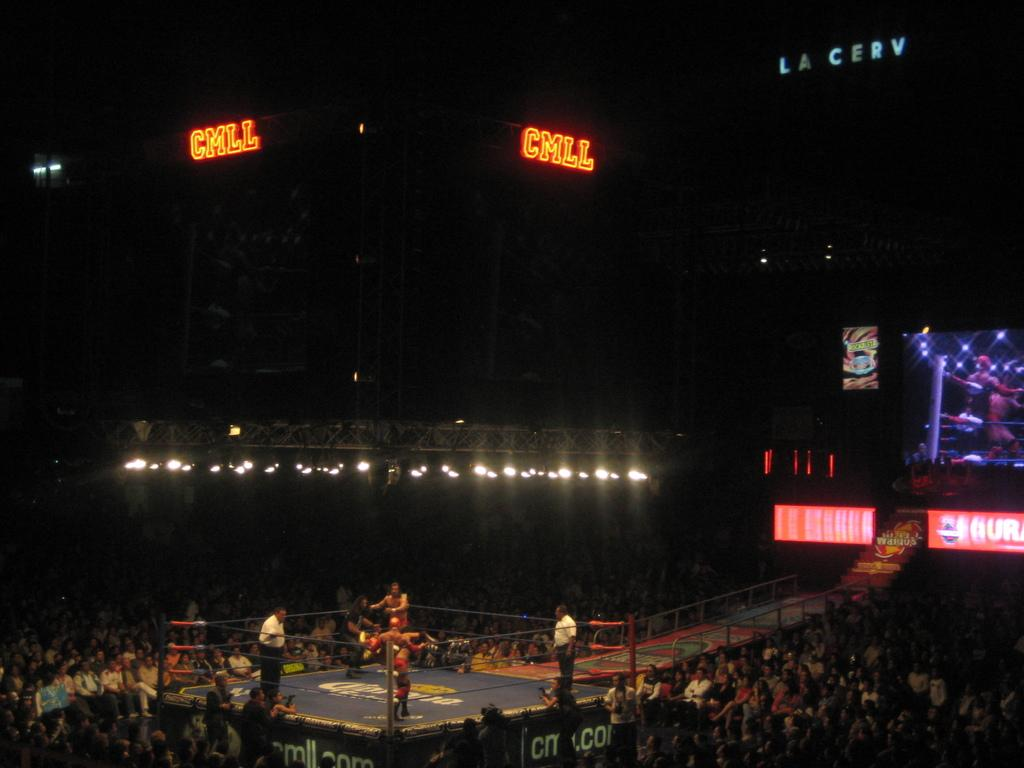<image>
Provide a brief description of the given image. the letters cmll that are above the ring 